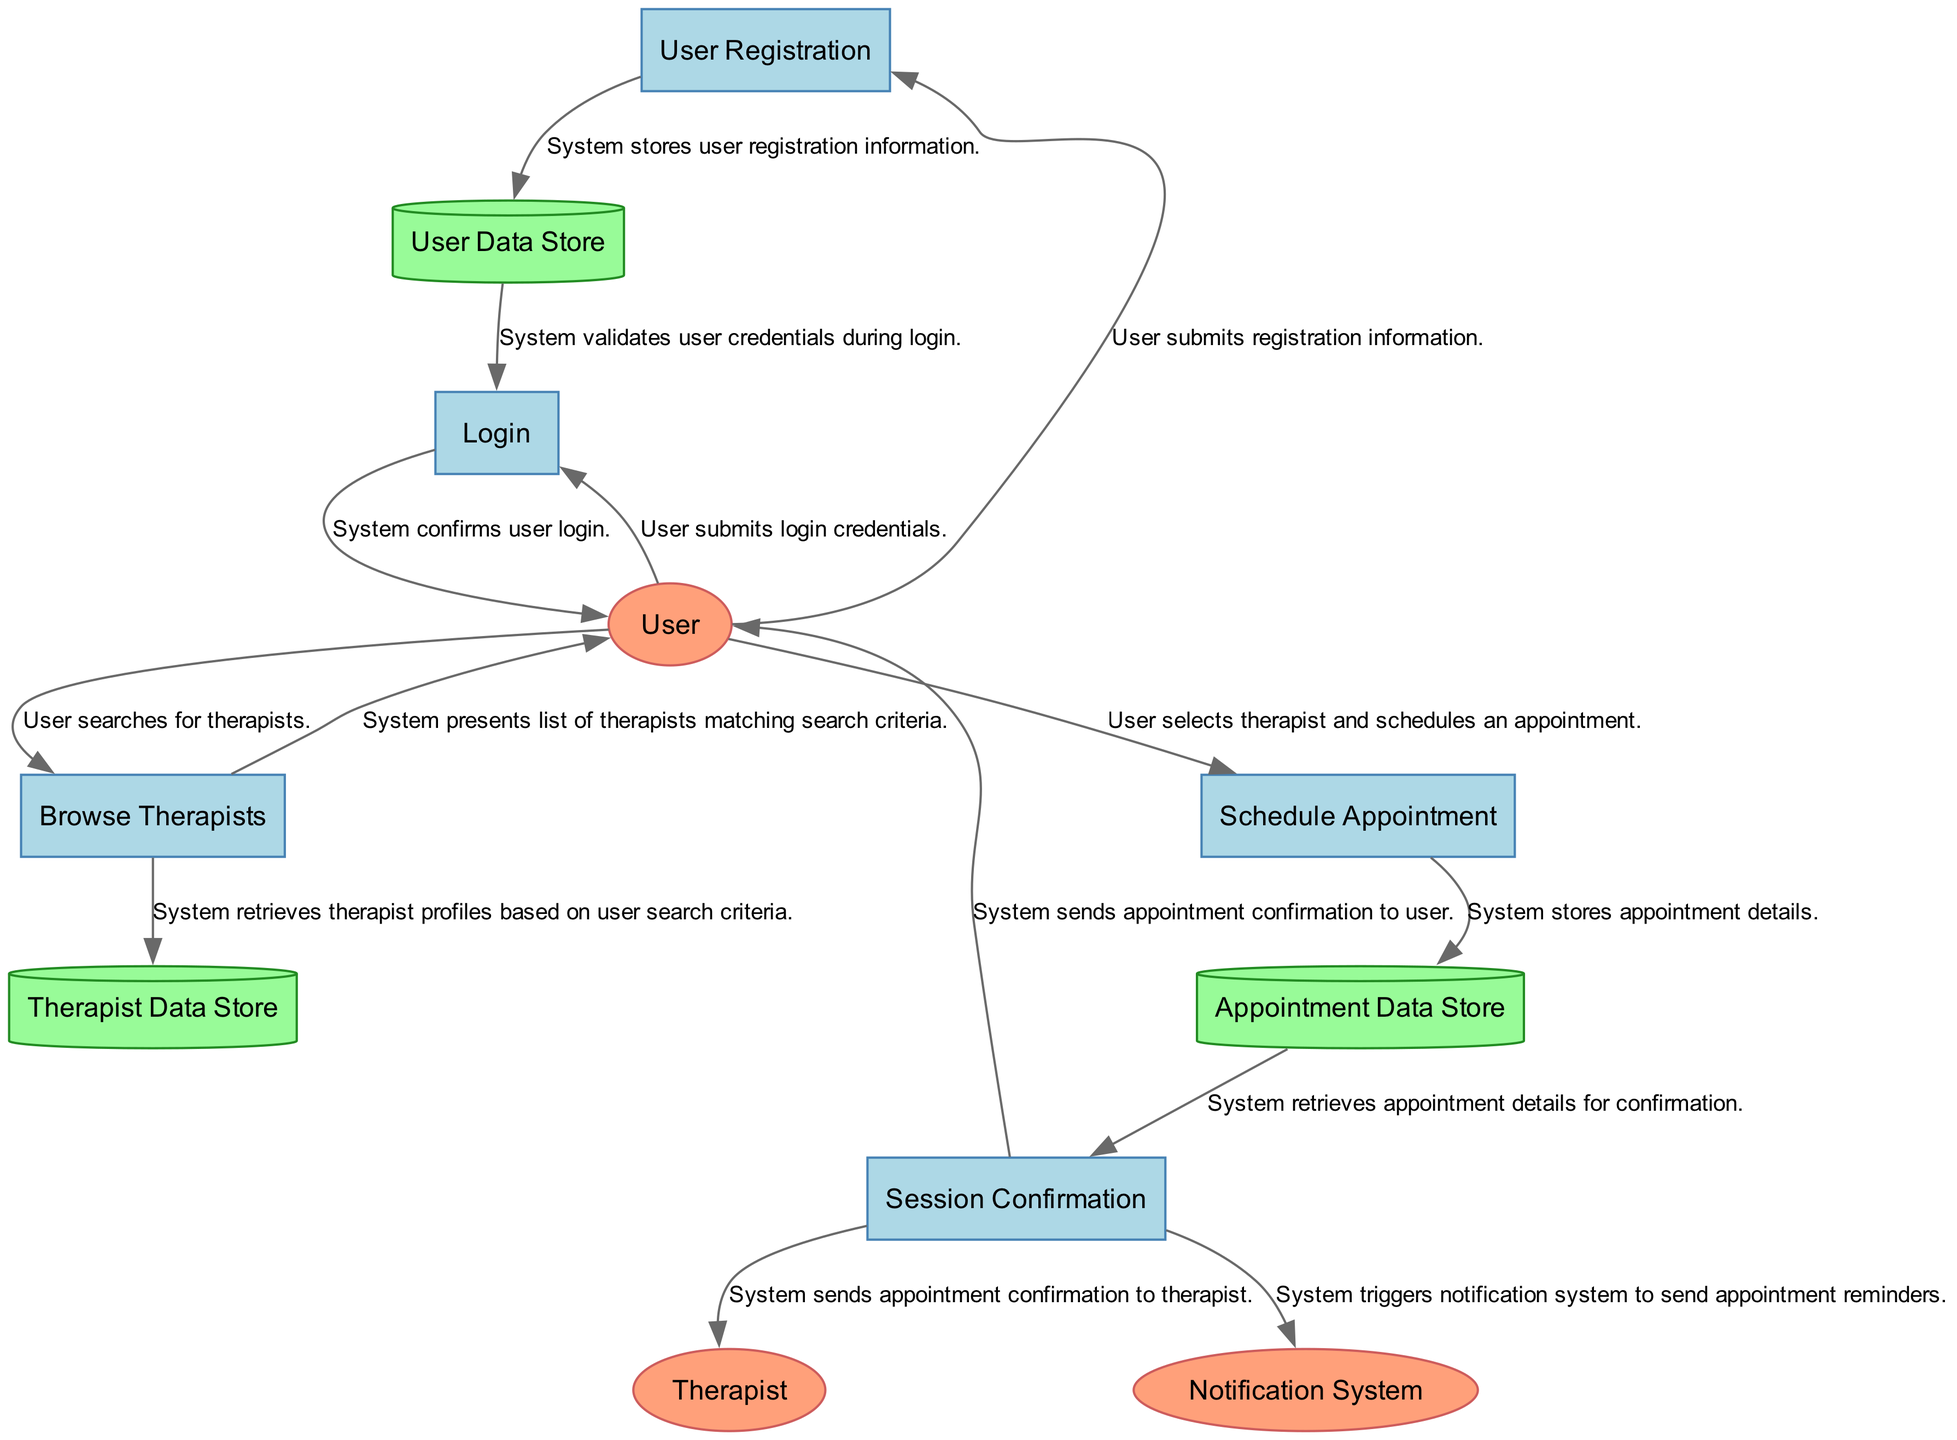What is the first process in the diagram? The first process is identified as "User Registration," which is designated as P1 in the diagram. It is the initial step that occurs after a user decides to engage with the therapy platform.
Answer: User Registration How many data stores are present in the diagram? The diagram lists three data stores: User Data Store, Therapist Data Store, and Appointment Data Store. The count is simply derived from the unique data stores shown in the design.
Answer: 3 What is the source entity for the "Browse Therapists" process? The source entity for this process is the User, marked as E1 in the diagram, who initiates the process by searching for therapists.
Answer: User Which process retrieves therapist profiles? The "Browse Therapists" process, identified as P3, is responsible for retrieving therapist profiles from the Therapist Data Store. This is indicated by the data flow from the process to the data store.
Answer: Browse Therapists What action follows "Schedule Appointment"? After the "Schedule Appointment" process, designated as P4, the next action is "Session Confirmation," which confirms the appointment details. This relationship is shown in the flow from P4 to P5.
Answer: Session Confirmation What type of external entity is the "Notification System"? The "Notification System" is an external entity responsible for sending notifications, such as reminders, to users and therapists; it is labeled as E3 within the diagram.
Answer: External system Who receives the appointment confirmation after scheduling? Both the User and the Therapist receive appointment confirmations after scheduling, as indicated by the data flows leading to E1 and E2 from the "Session Confirmation" process.
Answer: User and Therapist Which data store holds user credentials? The User Data Store, identified as D1, is the specific data store that contains the user information and credentials. This is indicated in the diagram as directly associated with the User Registration process.
Answer: User Data Store What occurs after user registration information is stored? After the user registration information is stored in the User Data Store (D1), the system proceeds to the Login process (P2), where it validates the user credentials.
Answer: Login process 